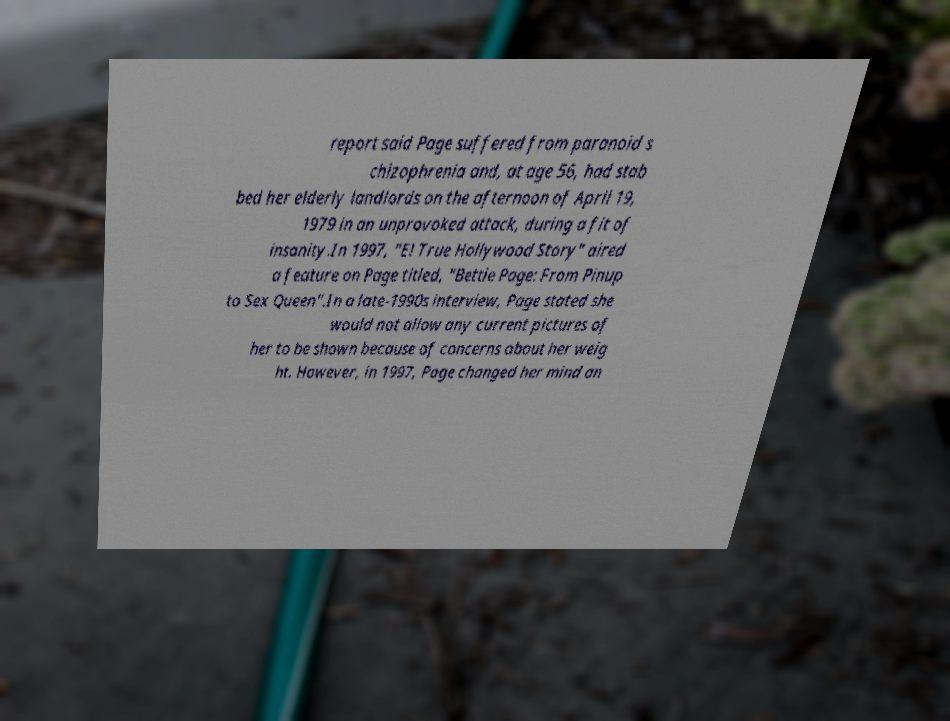Please identify and transcribe the text found in this image. report said Page suffered from paranoid s chizophrenia and, at age 56, had stab bed her elderly landlords on the afternoon of April 19, 1979 in an unprovoked attack, during a fit of insanity.In 1997, "E! True Hollywood Story" aired a feature on Page titled, "Bettie Page: From Pinup to Sex Queen".In a late-1990s interview, Page stated she would not allow any current pictures of her to be shown because of concerns about her weig ht. However, in 1997, Page changed her mind an 